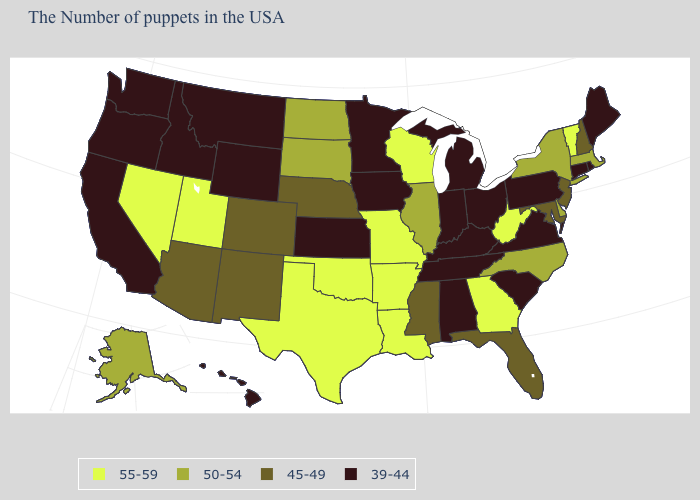Among the states that border South Carolina , which have the highest value?
Short answer required. Georgia. Name the states that have a value in the range 45-49?
Be succinct. New Hampshire, New Jersey, Maryland, Florida, Mississippi, Nebraska, Colorado, New Mexico, Arizona. What is the value of Maryland?
Quick response, please. 45-49. Which states have the lowest value in the USA?
Keep it brief. Maine, Rhode Island, Connecticut, Pennsylvania, Virginia, South Carolina, Ohio, Michigan, Kentucky, Indiana, Alabama, Tennessee, Minnesota, Iowa, Kansas, Wyoming, Montana, Idaho, California, Washington, Oregon, Hawaii. Does Kansas have a lower value than Alaska?
Be succinct. Yes. Does Utah have the highest value in the West?
Give a very brief answer. Yes. What is the lowest value in the West?
Be succinct. 39-44. What is the lowest value in states that border Nevada?
Give a very brief answer. 39-44. What is the value of Wisconsin?
Quick response, please. 55-59. What is the highest value in states that border Colorado?
Short answer required. 55-59. Does Delaware have the same value as West Virginia?
Concise answer only. No. Does Minnesota have the highest value in the MidWest?
Quick response, please. No. Which states have the lowest value in the USA?
Be succinct. Maine, Rhode Island, Connecticut, Pennsylvania, Virginia, South Carolina, Ohio, Michigan, Kentucky, Indiana, Alabama, Tennessee, Minnesota, Iowa, Kansas, Wyoming, Montana, Idaho, California, Washington, Oregon, Hawaii. Does the first symbol in the legend represent the smallest category?
Give a very brief answer. No. 